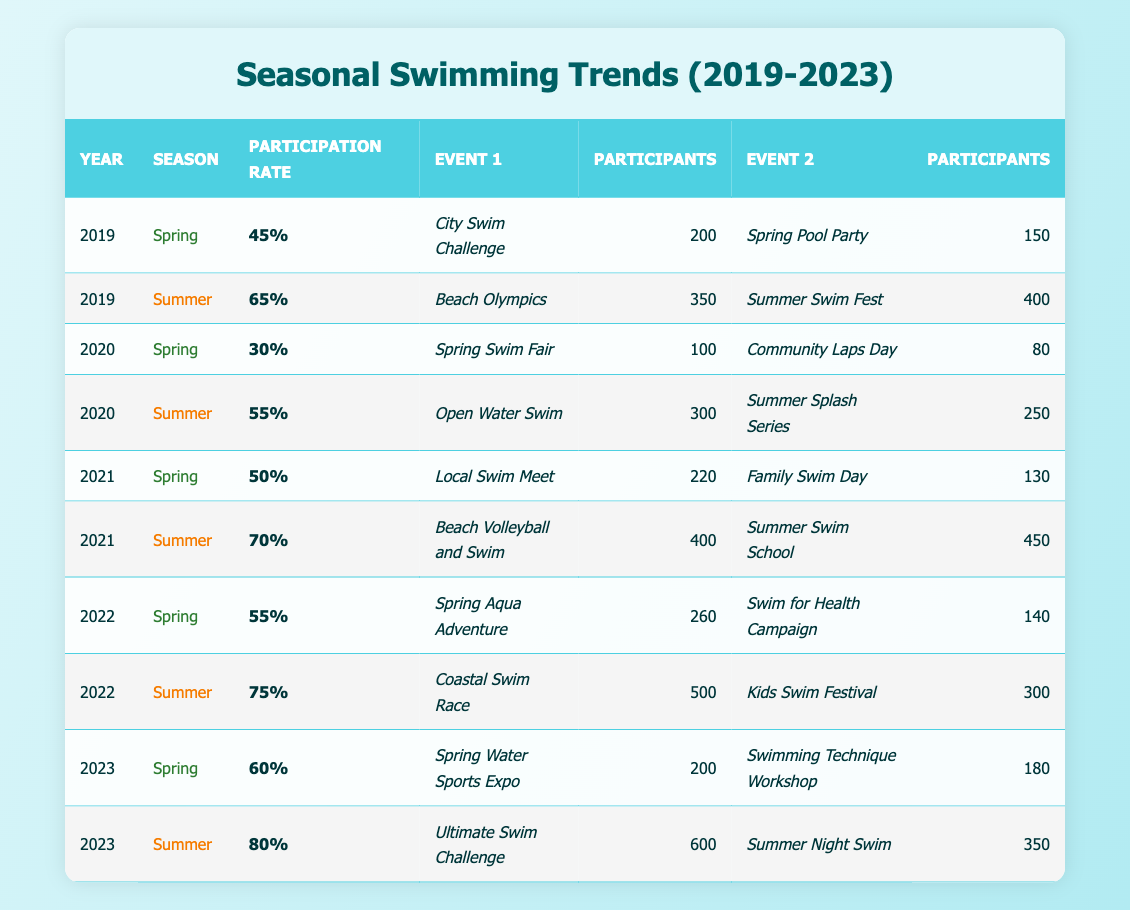What was the participation rate in Summer 2022? To find the participation rate for Summer 2022, locate the row corresponding to that season and year in the table. The rate is listed as 75%.
Answer: 75% Which event had the highest number of participants in Summer 2023? In the Summer 2023 row, the events listed are the Ultimate Swim Challenge with 600 participants and the Summer Night Swim with 350 participants. The Ultimate Swim Challenge has the highest number.
Answer: Ultimate Swim Challenge Overall, how many participants were there for Spring events in 2021? For Spring 2021, there are two events: the Local Swim Meet with 220 participants and the Family Swim Day with 130 participants. Adding these gives 220 + 130 = 350 participants.
Answer: 350 Did the participation rate in Summer 2020 increase from Spring 2020? The participation rate in Spring 2020 is 30%, while in Summer 2020 it is 55%. Since 55% is greater than 30%, it confirms an increase.
Answer: Yes What was the average participation rate across all years and seasons? To find the average participation rate, sum all participation rates: 45 + 65 + 30 + 55 + 50 + 70 + 55 + 75 + 60 + 80 = 715. There are 10 data points, so the average participation rate is 715 / 10 = 71.5%.
Answer: 71.5% 